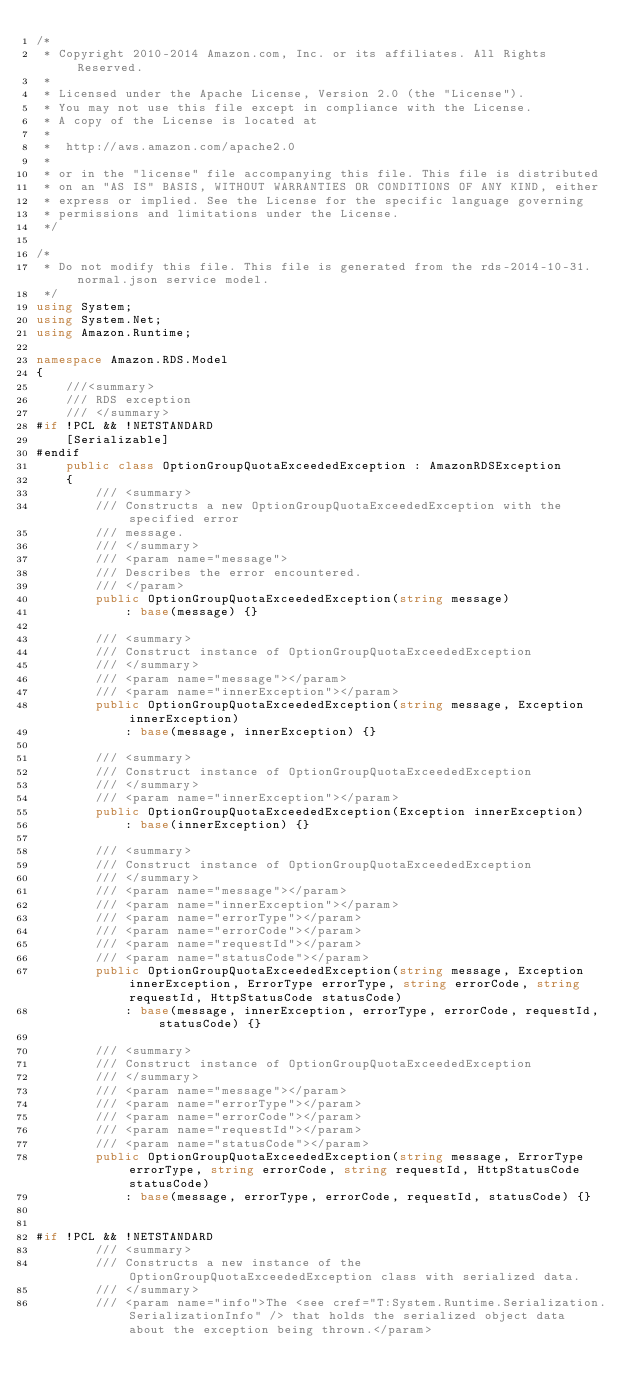<code> <loc_0><loc_0><loc_500><loc_500><_C#_>/*
 * Copyright 2010-2014 Amazon.com, Inc. or its affiliates. All Rights Reserved.
 * 
 * Licensed under the Apache License, Version 2.0 (the "License").
 * You may not use this file except in compliance with the License.
 * A copy of the License is located at
 * 
 *  http://aws.amazon.com/apache2.0
 * 
 * or in the "license" file accompanying this file. This file is distributed
 * on an "AS IS" BASIS, WITHOUT WARRANTIES OR CONDITIONS OF ANY KIND, either
 * express or implied. See the License for the specific language governing
 * permissions and limitations under the License.
 */

/*
 * Do not modify this file. This file is generated from the rds-2014-10-31.normal.json service model.
 */
using System;
using System.Net;
using Amazon.Runtime;

namespace Amazon.RDS.Model
{
    ///<summary>
    /// RDS exception
    /// </summary>
#if !PCL && !NETSTANDARD
    [Serializable]
#endif
    public class OptionGroupQuotaExceededException : AmazonRDSException 
    {
        /// <summary>
        /// Constructs a new OptionGroupQuotaExceededException with the specified error
        /// message.
        /// </summary>
        /// <param name="message">
        /// Describes the error encountered.
        /// </param>
        public OptionGroupQuotaExceededException(string message) 
            : base(message) {}
          
        /// <summary>
        /// Construct instance of OptionGroupQuotaExceededException
        /// </summary>
        /// <param name="message"></param>
        /// <param name="innerException"></param>
        public OptionGroupQuotaExceededException(string message, Exception innerException) 
            : base(message, innerException) {}
            
        /// <summary>
        /// Construct instance of OptionGroupQuotaExceededException
        /// </summary>
        /// <param name="innerException"></param>
        public OptionGroupQuotaExceededException(Exception innerException) 
            : base(innerException) {}
            
        /// <summary>
        /// Construct instance of OptionGroupQuotaExceededException
        /// </summary>
        /// <param name="message"></param>
        /// <param name="innerException"></param>
        /// <param name="errorType"></param>
        /// <param name="errorCode"></param>
        /// <param name="requestId"></param>
        /// <param name="statusCode"></param>
        public OptionGroupQuotaExceededException(string message, Exception innerException, ErrorType errorType, string errorCode, string requestId, HttpStatusCode statusCode) 
            : base(message, innerException, errorType, errorCode, requestId, statusCode) {}

        /// <summary>
        /// Construct instance of OptionGroupQuotaExceededException
        /// </summary>
        /// <param name="message"></param>
        /// <param name="errorType"></param>
        /// <param name="errorCode"></param>
        /// <param name="requestId"></param>
        /// <param name="statusCode"></param>
        public OptionGroupQuotaExceededException(string message, ErrorType errorType, string errorCode, string requestId, HttpStatusCode statusCode) 
            : base(message, errorType, errorCode, requestId, statusCode) {}


#if !PCL && !NETSTANDARD
        /// <summary>
        /// Constructs a new instance of the OptionGroupQuotaExceededException class with serialized data.
        /// </summary>
        /// <param name="info">The <see cref="T:System.Runtime.Serialization.SerializationInfo" /> that holds the serialized object data about the exception being thrown.</param></code> 